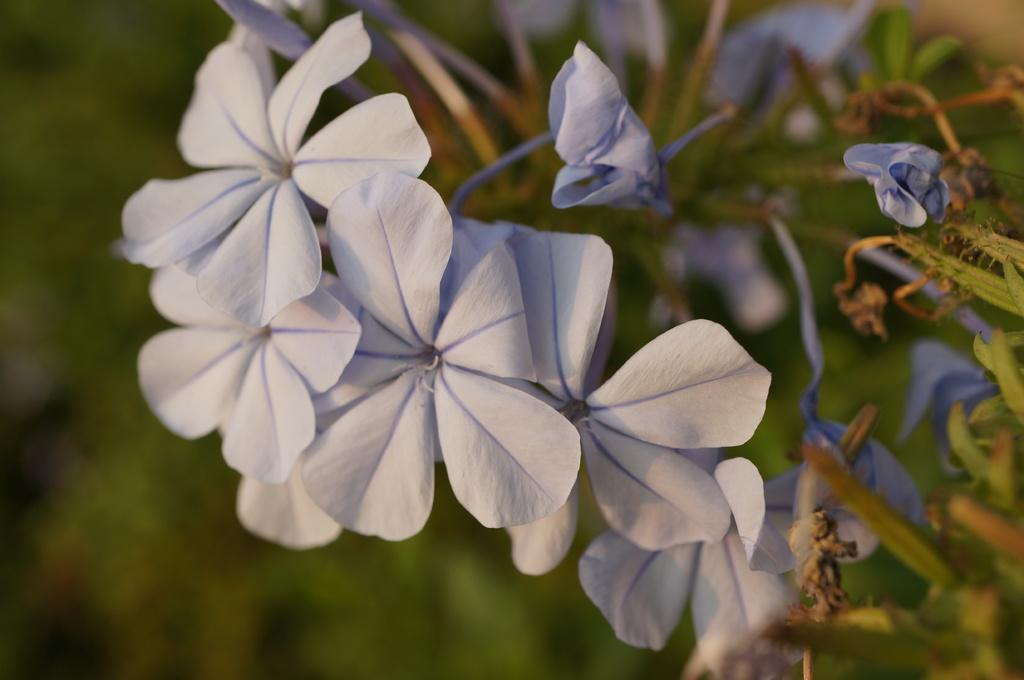What is the main subject of the image? There is a plant in the image. What color are the flowers on the plant? The plant has white flowers. Can you describe the background of the image? The background of the image is blurred. How many screws can be seen holding the coal together in the image? There is no coal or screws present in the image; it features a plant with white flowers and a blurred background. 